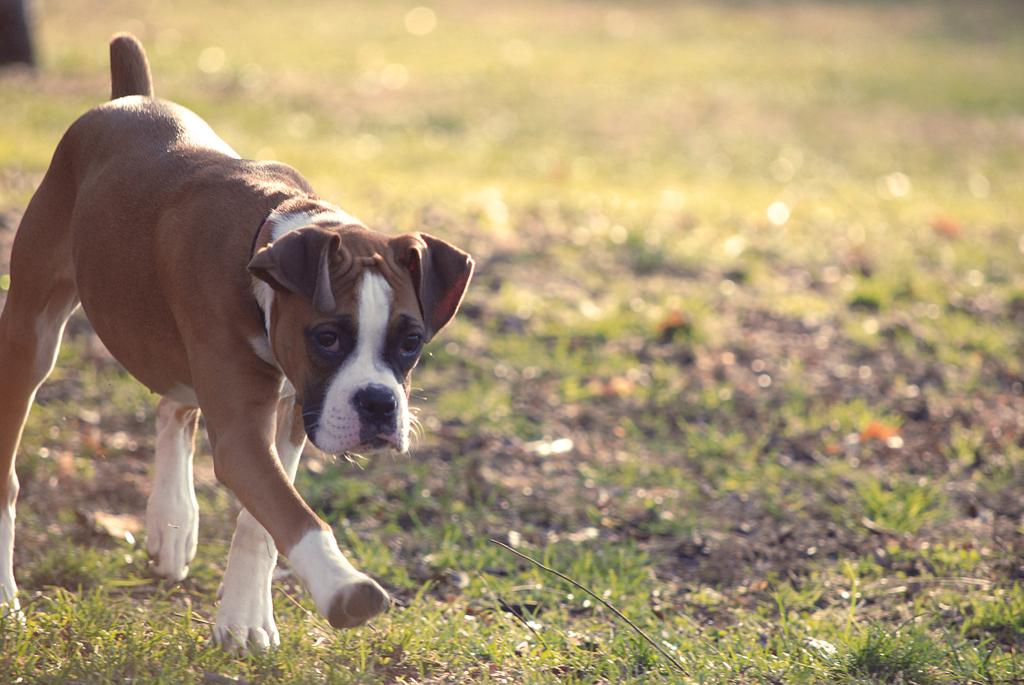What animal is present in the image? There is a dog in the image. What is the dog doing in the image? The dog is walking on the grass. Can you describe the background of the image? The background of the image is blurred. How many islands can be seen in the image? There are no islands present in the image; it features a dog walking on the grass. What type of beam is holding up the dog in the image? There is no beam present in the image; the dog is walking on the grass without any support. 